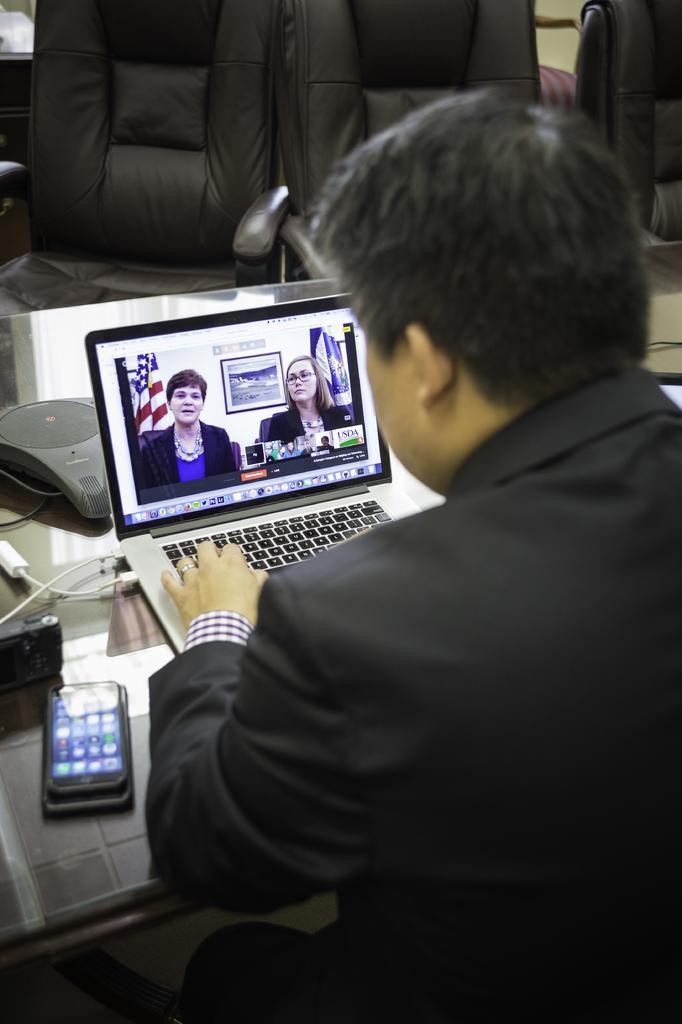What is the main subject of the image? There is a man in the image. What is the man doing in the image? The man's hand is on a laptop. What other object can be seen on the table? There is a phone on the table. How many chairs are visible in the background? There are three chairs in the background. Can you hear the stranger coughing in the image? There is no stranger or coughing sound present in the image. 